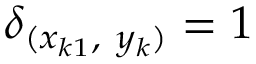<formula> <loc_0><loc_0><loc_500><loc_500>\delta _ { ( x _ { k 1 } , y _ { k } ) } = 1</formula> 